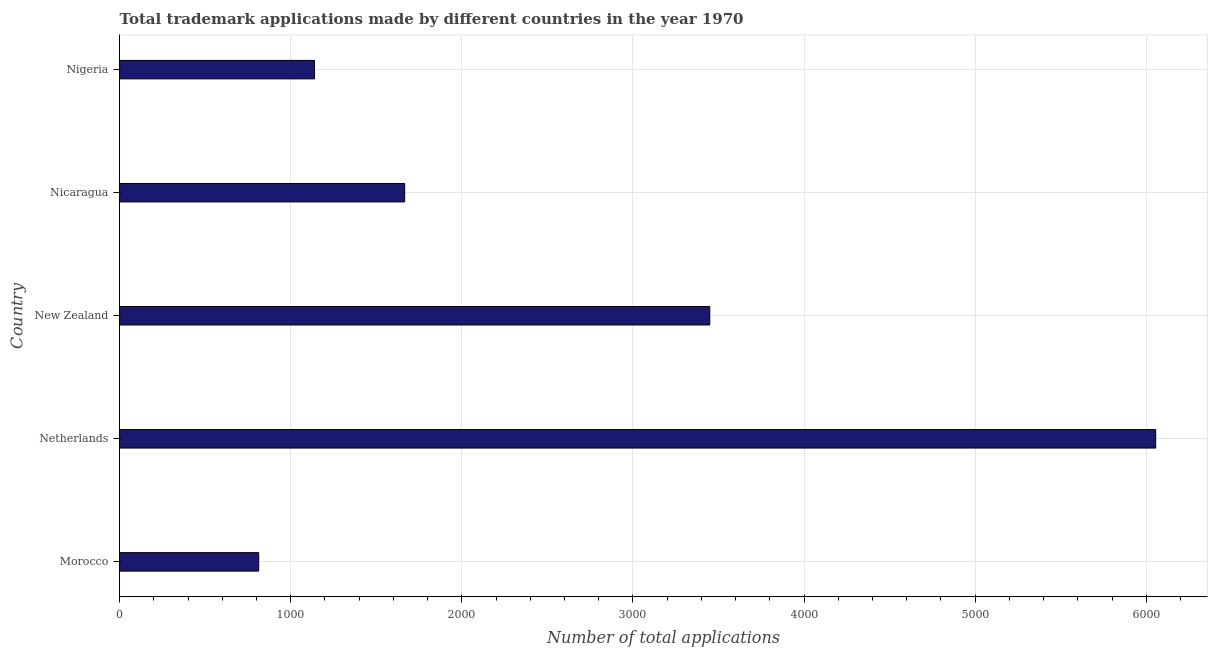Does the graph contain any zero values?
Provide a short and direct response. No. Does the graph contain grids?
Ensure brevity in your answer.  Yes. What is the title of the graph?
Offer a very short reply. Total trademark applications made by different countries in the year 1970. What is the label or title of the X-axis?
Provide a succinct answer. Number of total applications. What is the number of trademark applications in New Zealand?
Provide a succinct answer. 3449. Across all countries, what is the maximum number of trademark applications?
Offer a very short reply. 6055. Across all countries, what is the minimum number of trademark applications?
Keep it short and to the point. 813. In which country was the number of trademark applications maximum?
Keep it short and to the point. Netherlands. In which country was the number of trademark applications minimum?
Offer a terse response. Morocco. What is the sum of the number of trademark applications?
Ensure brevity in your answer.  1.31e+04. What is the difference between the number of trademark applications in Morocco and Netherlands?
Ensure brevity in your answer.  -5242. What is the average number of trademark applications per country?
Give a very brief answer. 2624. What is the median number of trademark applications?
Your answer should be very brief. 1666. What is the ratio of the number of trademark applications in Netherlands to that in Nigeria?
Give a very brief answer. 5.32. Is the difference between the number of trademark applications in Morocco and Nicaragua greater than the difference between any two countries?
Keep it short and to the point. No. What is the difference between the highest and the second highest number of trademark applications?
Provide a succinct answer. 2606. Is the sum of the number of trademark applications in Morocco and Nigeria greater than the maximum number of trademark applications across all countries?
Offer a very short reply. No. What is the difference between the highest and the lowest number of trademark applications?
Your answer should be very brief. 5242. How many bars are there?
Offer a terse response. 5. How many countries are there in the graph?
Ensure brevity in your answer.  5. What is the Number of total applications of Morocco?
Your answer should be very brief. 813. What is the Number of total applications of Netherlands?
Keep it short and to the point. 6055. What is the Number of total applications in New Zealand?
Provide a succinct answer. 3449. What is the Number of total applications in Nicaragua?
Provide a succinct answer. 1666. What is the Number of total applications in Nigeria?
Your answer should be compact. 1139. What is the difference between the Number of total applications in Morocco and Netherlands?
Give a very brief answer. -5242. What is the difference between the Number of total applications in Morocco and New Zealand?
Offer a terse response. -2636. What is the difference between the Number of total applications in Morocco and Nicaragua?
Your answer should be very brief. -853. What is the difference between the Number of total applications in Morocco and Nigeria?
Your response must be concise. -326. What is the difference between the Number of total applications in Netherlands and New Zealand?
Give a very brief answer. 2606. What is the difference between the Number of total applications in Netherlands and Nicaragua?
Offer a terse response. 4389. What is the difference between the Number of total applications in Netherlands and Nigeria?
Ensure brevity in your answer.  4916. What is the difference between the Number of total applications in New Zealand and Nicaragua?
Provide a short and direct response. 1783. What is the difference between the Number of total applications in New Zealand and Nigeria?
Offer a very short reply. 2310. What is the difference between the Number of total applications in Nicaragua and Nigeria?
Keep it short and to the point. 527. What is the ratio of the Number of total applications in Morocco to that in Netherlands?
Provide a succinct answer. 0.13. What is the ratio of the Number of total applications in Morocco to that in New Zealand?
Offer a very short reply. 0.24. What is the ratio of the Number of total applications in Morocco to that in Nicaragua?
Offer a very short reply. 0.49. What is the ratio of the Number of total applications in Morocco to that in Nigeria?
Give a very brief answer. 0.71. What is the ratio of the Number of total applications in Netherlands to that in New Zealand?
Offer a very short reply. 1.76. What is the ratio of the Number of total applications in Netherlands to that in Nicaragua?
Your response must be concise. 3.63. What is the ratio of the Number of total applications in Netherlands to that in Nigeria?
Your response must be concise. 5.32. What is the ratio of the Number of total applications in New Zealand to that in Nicaragua?
Your answer should be very brief. 2.07. What is the ratio of the Number of total applications in New Zealand to that in Nigeria?
Offer a terse response. 3.03. What is the ratio of the Number of total applications in Nicaragua to that in Nigeria?
Keep it short and to the point. 1.46. 